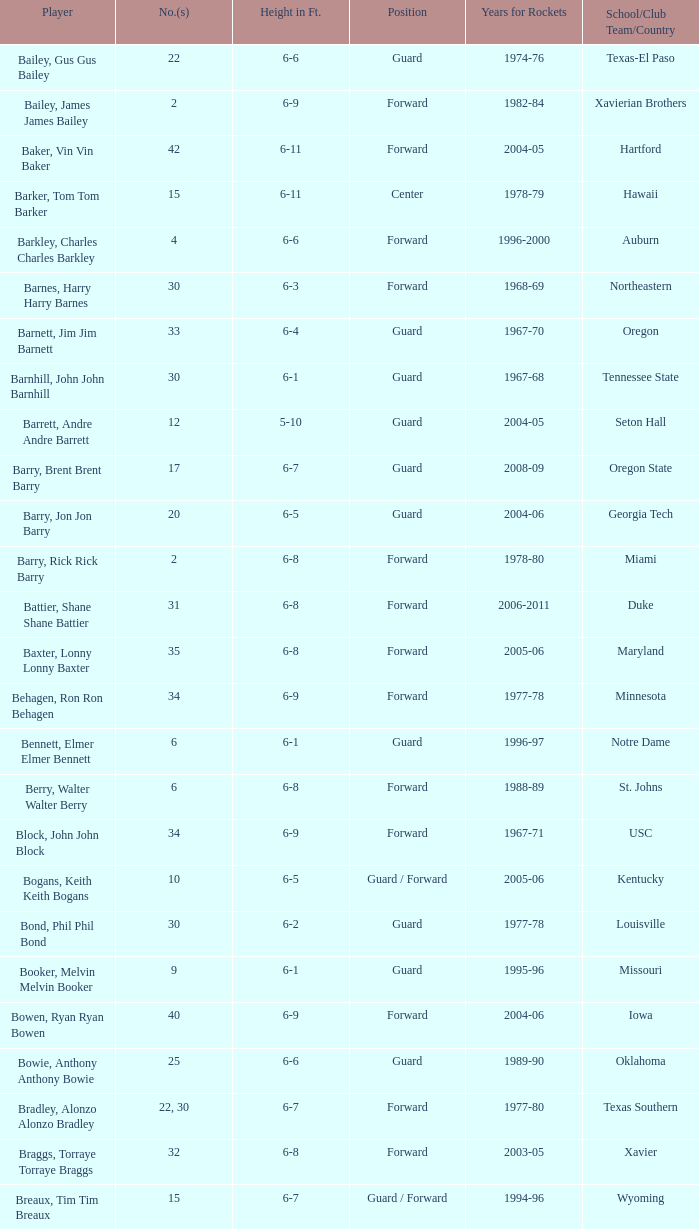To which school did the number 10 forward belong? Arizona. 